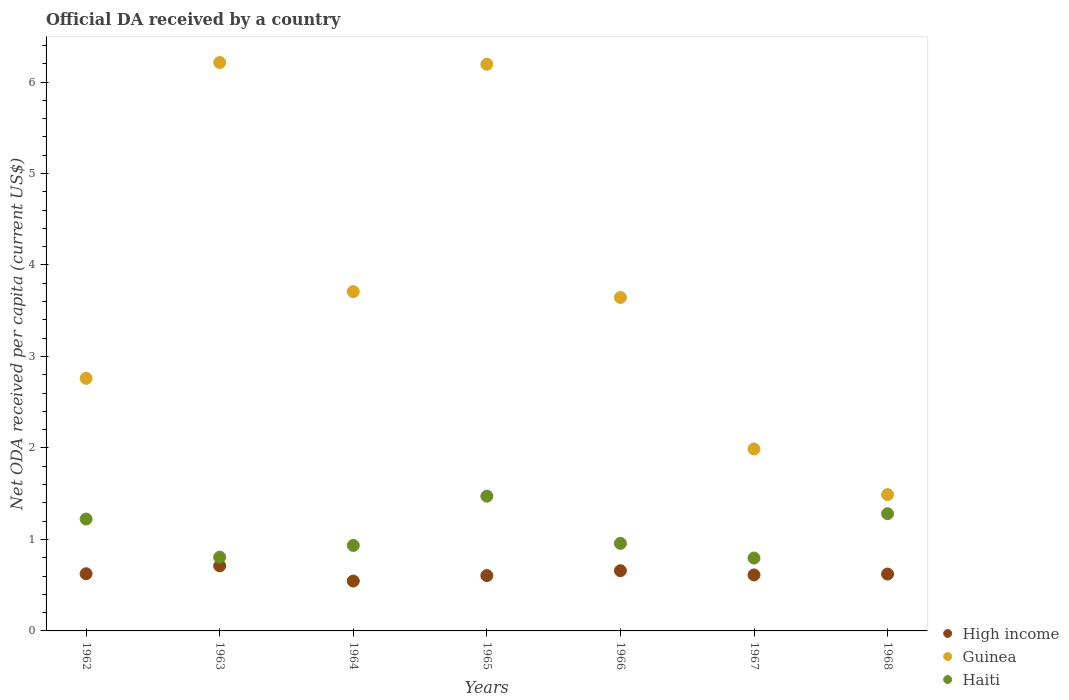How many different coloured dotlines are there?
Offer a terse response. 3. What is the ODA received in in High income in 1963?
Offer a terse response. 0.71. Across all years, what is the maximum ODA received in in High income?
Make the answer very short. 0.71. Across all years, what is the minimum ODA received in in Guinea?
Offer a very short reply. 1.49. In which year was the ODA received in in Guinea maximum?
Ensure brevity in your answer.  1963. In which year was the ODA received in in Guinea minimum?
Your answer should be compact. 1968. What is the total ODA received in in High income in the graph?
Make the answer very short. 4.38. What is the difference between the ODA received in in Guinea in 1964 and that in 1968?
Give a very brief answer. 2.22. What is the difference between the ODA received in in High income in 1964 and the ODA received in in Haiti in 1963?
Provide a succinct answer. -0.26. What is the average ODA received in in High income per year?
Make the answer very short. 0.63. In the year 1963, what is the difference between the ODA received in in High income and ODA received in in Guinea?
Your response must be concise. -5.5. In how many years, is the ODA received in in High income greater than 1.2 US$?
Offer a very short reply. 0. What is the ratio of the ODA received in in High income in 1962 to that in 1967?
Make the answer very short. 1.02. Is the difference between the ODA received in in High income in 1967 and 1968 greater than the difference between the ODA received in in Guinea in 1967 and 1968?
Your response must be concise. No. What is the difference between the highest and the second highest ODA received in in High income?
Offer a terse response. 0.05. What is the difference between the highest and the lowest ODA received in in High income?
Give a very brief answer. 0.17. In how many years, is the ODA received in in Guinea greater than the average ODA received in in Guinea taken over all years?
Provide a short and direct response. 2. Does the ODA received in in Guinea monotonically increase over the years?
Your response must be concise. No. Is the ODA received in in High income strictly less than the ODA received in in Haiti over the years?
Your answer should be very brief. Yes. How many dotlines are there?
Provide a short and direct response. 3. What is the difference between two consecutive major ticks on the Y-axis?
Ensure brevity in your answer.  1. Does the graph contain any zero values?
Keep it short and to the point. No. How many legend labels are there?
Offer a very short reply. 3. What is the title of the graph?
Offer a terse response. Official DA received by a country. Does "Lesotho" appear as one of the legend labels in the graph?
Provide a short and direct response. No. What is the label or title of the X-axis?
Offer a terse response. Years. What is the label or title of the Y-axis?
Your answer should be compact. Net ODA received per capita (current US$). What is the Net ODA received per capita (current US$) of High income in 1962?
Your answer should be compact. 0.63. What is the Net ODA received per capita (current US$) in Guinea in 1962?
Your response must be concise. 2.76. What is the Net ODA received per capita (current US$) in Haiti in 1962?
Provide a succinct answer. 1.22. What is the Net ODA received per capita (current US$) of High income in 1963?
Your response must be concise. 0.71. What is the Net ODA received per capita (current US$) of Guinea in 1963?
Your answer should be very brief. 6.21. What is the Net ODA received per capita (current US$) in Haiti in 1963?
Provide a succinct answer. 0.81. What is the Net ODA received per capita (current US$) of High income in 1964?
Keep it short and to the point. 0.55. What is the Net ODA received per capita (current US$) in Guinea in 1964?
Offer a terse response. 3.71. What is the Net ODA received per capita (current US$) of Haiti in 1964?
Your answer should be very brief. 0.93. What is the Net ODA received per capita (current US$) in High income in 1965?
Your answer should be compact. 0.61. What is the Net ODA received per capita (current US$) in Guinea in 1965?
Your answer should be compact. 6.19. What is the Net ODA received per capita (current US$) in Haiti in 1965?
Your answer should be very brief. 1.47. What is the Net ODA received per capita (current US$) of High income in 1966?
Your answer should be very brief. 0.66. What is the Net ODA received per capita (current US$) of Guinea in 1966?
Provide a succinct answer. 3.64. What is the Net ODA received per capita (current US$) in Haiti in 1966?
Give a very brief answer. 0.96. What is the Net ODA received per capita (current US$) of High income in 1967?
Your answer should be very brief. 0.61. What is the Net ODA received per capita (current US$) in Guinea in 1967?
Your response must be concise. 1.99. What is the Net ODA received per capita (current US$) in Haiti in 1967?
Keep it short and to the point. 0.8. What is the Net ODA received per capita (current US$) of High income in 1968?
Make the answer very short. 0.62. What is the Net ODA received per capita (current US$) in Guinea in 1968?
Provide a short and direct response. 1.49. What is the Net ODA received per capita (current US$) in Haiti in 1968?
Provide a succinct answer. 1.28. Across all years, what is the maximum Net ODA received per capita (current US$) of High income?
Ensure brevity in your answer.  0.71. Across all years, what is the maximum Net ODA received per capita (current US$) of Guinea?
Make the answer very short. 6.21. Across all years, what is the maximum Net ODA received per capita (current US$) of Haiti?
Provide a short and direct response. 1.47. Across all years, what is the minimum Net ODA received per capita (current US$) in High income?
Your answer should be very brief. 0.55. Across all years, what is the minimum Net ODA received per capita (current US$) in Guinea?
Your answer should be very brief. 1.49. Across all years, what is the minimum Net ODA received per capita (current US$) of Haiti?
Offer a very short reply. 0.8. What is the total Net ODA received per capita (current US$) in High income in the graph?
Your answer should be very brief. 4.38. What is the total Net ODA received per capita (current US$) of Guinea in the graph?
Provide a succinct answer. 26. What is the total Net ODA received per capita (current US$) of Haiti in the graph?
Offer a very short reply. 7.47. What is the difference between the Net ODA received per capita (current US$) of High income in 1962 and that in 1963?
Your answer should be very brief. -0.09. What is the difference between the Net ODA received per capita (current US$) of Guinea in 1962 and that in 1963?
Your answer should be very brief. -3.45. What is the difference between the Net ODA received per capita (current US$) in Haiti in 1962 and that in 1963?
Your response must be concise. 0.42. What is the difference between the Net ODA received per capita (current US$) of High income in 1962 and that in 1964?
Make the answer very short. 0.08. What is the difference between the Net ODA received per capita (current US$) of Guinea in 1962 and that in 1964?
Make the answer very short. -0.95. What is the difference between the Net ODA received per capita (current US$) in Haiti in 1962 and that in 1964?
Offer a very short reply. 0.29. What is the difference between the Net ODA received per capita (current US$) of Guinea in 1962 and that in 1965?
Provide a succinct answer. -3.43. What is the difference between the Net ODA received per capita (current US$) in Haiti in 1962 and that in 1965?
Your answer should be very brief. -0.25. What is the difference between the Net ODA received per capita (current US$) in High income in 1962 and that in 1966?
Keep it short and to the point. -0.03. What is the difference between the Net ODA received per capita (current US$) of Guinea in 1962 and that in 1966?
Offer a terse response. -0.88. What is the difference between the Net ODA received per capita (current US$) of Haiti in 1962 and that in 1966?
Make the answer very short. 0.27. What is the difference between the Net ODA received per capita (current US$) in High income in 1962 and that in 1967?
Ensure brevity in your answer.  0.01. What is the difference between the Net ODA received per capita (current US$) in Guinea in 1962 and that in 1967?
Your answer should be compact. 0.77. What is the difference between the Net ODA received per capita (current US$) in Haiti in 1962 and that in 1967?
Offer a very short reply. 0.43. What is the difference between the Net ODA received per capita (current US$) of High income in 1962 and that in 1968?
Ensure brevity in your answer.  0. What is the difference between the Net ODA received per capita (current US$) in Guinea in 1962 and that in 1968?
Your response must be concise. 1.27. What is the difference between the Net ODA received per capita (current US$) in Haiti in 1962 and that in 1968?
Give a very brief answer. -0.06. What is the difference between the Net ODA received per capita (current US$) of High income in 1963 and that in 1964?
Provide a succinct answer. 0.17. What is the difference between the Net ODA received per capita (current US$) of Guinea in 1963 and that in 1964?
Your response must be concise. 2.5. What is the difference between the Net ODA received per capita (current US$) of Haiti in 1963 and that in 1964?
Provide a succinct answer. -0.13. What is the difference between the Net ODA received per capita (current US$) in High income in 1963 and that in 1965?
Offer a terse response. 0.11. What is the difference between the Net ODA received per capita (current US$) of Guinea in 1963 and that in 1965?
Make the answer very short. 0.02. What is the difference between the Net ODA received per capita (current US$) in Haiti in 1963 and that in 1965?
Provide a short and direct response. -0.67. What is the difference between the Net ODA received per capita (current US$) of High income in 1963 and that in 1966?
Offer a very short reply. 0.05. What is the difference between the Net ODA received per capita (current US$) in Guinea in 1963 and that in 1966?
Your answer should be compact. 2.57. What is the difference between the Net ODA received per capita (current US$) in Haiti in 1963 and that in 1966?
Offer a terse response. -0.15. What is the difference between the Net ODA received per capita (current US$) in High income in 1963 and that in 1967?
Give a very brief answer. 0.1. What is the difference between the Net ODA received per capita (current US$) in Guinea in 1963 and that in 1967?
Make the answer very short. 4.22. What is the difference between the Net ODA received per capita (current US$) in Haiti in 1963 and that in 1967?
Ensure brevity in your answer.  0.01. What is the difference between the Net ODA received per capita (current US$) of High income in 1963 and that in 1968?
Give a very brief answer. 0.09. What is the difference between the Net ODA received per capita (current US$) in Guinea in 1963 and that in 1968?
Ensure brevity in your answer.  4.72. What is the difference between the Net ODA received per capita (current US$) in Haiti in 1963 and that in 1968?
Keep it short and to the point. -0.47. What is the difference between the Net ODA received per capita (current US$) in High income in 1964 and that in 1965?
Offer a terse response. -0.06. What is the difference between the Net ODA received per capita (current US$) of Guinea in 1964 and that in 1965?
Offer a very short reply. -2.48. What is the difference between the Net ODA received per capita (current US$) of Haiti in 1964 and that in 1965?
Make the answer very short. -0.54. What is the difference between the Net ODA received per capita (current US$) of High income in 1964 and that in 1966?
Provide a succinct answer. -0.11. What is the difference between the Net ODA received per capita (current US$) in Guinea in 1964 and that in 1966?
Offer a terse response. 0.06. What is the difference between the Net ODA received per capita (current US$) of Haiti in 1964 and that in 1966?
Your answer should be very brief. -0.02. What is the difference between the Net ODA received per capita (current US$) in High income in 1964 and that in 1967?
Give a very brief answer. -0.07. What is the difference between the Net ODA received per capita (current US$) in Guinea in 1964 and that in 1967?
Your response must be concise. 1.72. What is the difference between the Net ODA received per capita (current US$) in Haiti in 1964 and that in 1967?
Make the answer very short. 0.14. What is the difference between the Net ODA received per capita (current US$) of High income in 1964 and that in 1968?
Provide a short and direct response. -0.08. What is the difference between the Net ODA received per capita (current US$) of Guinea in 1964 and that in 1968?
Make the answer very short. 2.22. What is the difference between the Net ODA received per capita (current US$) of Haiti in 1964 and that in 1968?
Offer a terse response. -0.35. What is the difference between the Net ODA received per capita (current US$) of High income in 1965 and that in 1966?
Give a very brief answer. -0.05. What is the difference between the Net ODA received per capita (current US$) in Guinea in 1965 and that in 1966?
Provide a succinct answer. 2.55. What is the difference between the Net ODA received per capita (current US$) of Haiti in 1965 and that in 1966?
Provide a short and direct response. 0.52. What is the difference between the Net ODA received per capita (current US$) in High income in 1965 and that in 1967?
Your response must be concise. -0.01. What is the difference between the Net ODA received per capita (current US$) of Guinea in 1965 and that in 1967?
Your answer should be compact. 4.21. What is the difference between the Net ODA received per capita (current US$) in Haiti in 1965 and that in 1967?
Provide a succinct answer. 0.68. What is the difference between the Net ODA received per capita (current US$) in High income in 1965 and that in 1968?
Your response must be concise. -0.02. What is the difference between the Net ODA received per capita (current US$) of Guinea in 1965 and that in 1968?
Offer a very short reply. 4.7. What is the difference between the Net ODA received per capita (current US$) of Haiti in 1965 and that in 1968?
Give a very brief answer. 0.19. What is the difference between the Net ODA received per capita (current US$) of High income in 1966 and that in 1967?
Your answer should be compact. 0.05. What is the difference between the Net ODA received per capita (current US$) in Guinea in 1966 and that in 1967?
Your response must be concise. 1.66. What is the difference between the Net ODA received per capita (current US$) of Haiti in 1966 and that in 1967?
Make the answer very short. 0.16. What is the difference between the Net ODA received per capita (current US$) in High income in 1966 and that in 1968?
Keep it short and to the point. 0.04. What is the difference between the Net ODA received per capita (current US$) of Guinea in 1966 and that in 1968?
Your response must be concise. 2.15. What is the difference between the Net ODA received per capita (current US$) of Haiti in 1966 and that in 1968?
Keep it short and to the point. -0.32. What is the difference between the Net ODA received per capita (current US$) in High income in 1967 and that in 1968?
Make the answer very short. -0.01. What is the difference between the Net ODA received per capita (current US$) in Guinea in 1967 and that in 1968?
Keep it short and to the point. 0.5. What is the difference between the Net ODA received per capita (current US$) in Haiti in 1967 and that in 1968?
Provide a short and direct response. -0.49. What is the difference between the Net ODA received per capita (current US$) in High income in 1962 and the Net ODA received per capita (current US$) in Guinea in 1963?
Keep it short and to the point. -5.59. What is the difference between the Net ODA received per capita (current US$) of High income in 1962 and the Net ODA received per capita (current US$) of Haiti in 1963?
Keep it short and to the point. -0.18. What is the difference between the Net ODA received per capita (current US$) of Guinea in 1962 and the Net ODA received per capita (current US$) of Haiti in 1963?
Your answer should be compact. 1.95. What is the difference between the Net ODA received per capita (current US$) in High income in 1962 and the Net ODA received per capita (current US$) in Guinea in 1964?
Give a very brief answer. -3.08. What is the difference between the Net ODA received per capita (current US$) of High income in 1962 and the Net ODA received per capita (current US$) of Haiti in 1964?
Give a very brief answer. -0.31. What is the difference between the Net ODA received per capita (current US$) of Guinea in 1962 and the Net ODA received per capita (current US$) of Haiti in 1964?
Provide a short and direct response. 1.83. What is the difference between the Net ODA received per capita (current US$) in High income in 1962 and the Net ODA received per capita (current US$) in Guinea in 1965?
Give a very brief answer. -5.57. What is the difference between the Net ODA received per capita (current US$) of High income in 1962 and the Net ODA received per capita (current US$) of Haiti in 1965?
Offer a terse response. -0.85. What is the difference between the Net ODA received per capita (current US$) of Guinea in 1962 and the Net ODA received per capita (current US$) of Haiti in 1965?
Your answer should be very brief. 1.29. What is the difference between the Net ODA received per capita (current US$) in High income in 1962 and the Net ODA received per capita (current US$) in Guinea in 1966?
Offer a very short reply. -3.02. What is the difference between the Net ODA received per capita (current US$) in High income in 1962 and the Net ODA received per capita (current US$) in Haiti in 1966?
Provide a short and direct response. -0.33. What is the difference between the Net ODA received per capita (current US$) of Guinea in 1962 and the Net ODA received per capita (current US$) of Haiti in 1966?
Give a very brief answer. 1.8. What is the difference between the Net ODA received per capita (current US$) of High income in 1962 and the Net ODA received per capita (current US$) of Guinea in 1967?
Make the answer very short. -1.36. What is the difference between the Net ODA received per capita (current US$) in High income in 1962 and the Net ODA received per capita (current US$) in Haiti in 1967?
Your response must be concise. -0.17. What is the difference between the Net ODA received per capita (current US$) in Guinea in 1962 and the Net ODA received per capita (current US$) in Haiti in 1967?
Offer a very short reply. 1.96. What is the difference between the Net ODA received per capita (current US$) of High income in 1962 and the Net ODA received per capita (current US$) of Guinea in 1968?
Your answer should be very brief. -0.86. What is the difference between the Net ODA received per capita (current US$) of High income in 1962 and the Net ODA received per capita (current US$) of Haiti in 1968?
Ensure brevity in your answer.  -0.66. What is the difference between the Net ODA received per capita (current US$) in Guinea in 1962 and the Net ODA received per capita (current US$) in Haiti in 1968?
Make the answer very short. 1.48. What is the difference between the Net ODA received per capita (current US$) in High income in 1963 and the Net ODA received per capita (current US$) in Guinea in 1964?
Make the answer very short. -3. What is the difference between the Net ODA received per capita (current US$) of High income in 1963 and the Net ODA received per capita (current US$) of Haiti in 1964?
Give a very brief answer. -0.22. What is the difference between the Net ODA received per capita (current US$) of Guinea in 1963 and the Net ODA received per capita (current US$) of Haiti in 1964?
Keep it short and to the point. 5.28. What is the difference between the Net ODA received per capita (current US$) in High income in 1963 and the Net ODA received per capita (current US$) in Guinea in 1965?
Provide a short and direct response. -5.48. What is the difference between the Net ODA received per capita (current US$) of High income in 1963 and the Net ODA received per capita (current US$) of Haiti in 1965?
Make the answer very short. -0.76. What is the difference between the Net ODA received per capita (current US$) of Guinea in 1963 and the Net ODA received per capita (current US$) of Haiti in 1965?
Your answer should be compact. 4.74. What is the difference between the Net ODA received per capita (current US$) of High income in 1963 and the Net ODA received per capita (current US$) of Guinea in 1966?
Provide a succinct answer. -2.93. What is the difference between the Net ODA received per capita (current US$) of High income in 1963 and the Net ODA received per capita (current US$) of Haiti in 1966?
Give a very brief answer. -0.25. What is the difference between the Net ODA received per capita (current US$) in Guinea in 1963 and the Net ODA received per capita (current US$) in Haiti in 1966?
Give a very brief answer. 5.26. What is the difference between the Net ODA received per capita (current US$) in High income in 1963 and the Net ODA received per capita (current US$) in Guinea in 1967?
Your answer should be compact. -1.28. What is the difference between the Net ODA received per capita (current US$) in High income in 1963 and the Net ODA received per capita (current US$) in Haiti in 1967?
Offer a very short reply. -0.09. What is the difference between the Net ODA received per capita (current US$) in Guinea in 1963 and the Net ODA received per capita (current US$) in Haiti in 1967?
Offer a very short reply. 5.42. What is the difference between the Net ODA received per capita (current US$) in High income in 1963 and the Net ODA received per capita (current US$) in Guinea in 1968?
Your answer should be compact. -0.78. What is the difference between the Net ODA received per capita (current US$) of High income in 1963 and the Net ODA received per capita (current US$) of Haiti in 1968?
Provide a succinct answer. -0.57. What is the difference between the Net ODA received per capita (current US$) of Guinea in 1963 and the Net ODA received per capita (current US$) of Haiti in 1968?
Your response must be concise. 4.93. What is the difference between the Net ODA received per capita (current US$) of High income in 1964 and the Net ODA received per capita (current US$) of Guinea in 1965?
Give a very brief answer. -5.65. What is the difference between the Net ODA received per capita (current US$) of High income in 1964 and the Net ODA received per capita (current US$) of Haiti in 1965?
Provide a succinct answer. -0.93. What is the difference between the Net ODA received per capita (current US$) in Guinea in 1964 and the Net ODA received per capita (current US$) in Haiti in 1965?
Provide a short and direct response. 2.24. What is the difference between the Net ODA received per capita (current US$) in High income in 1964 and the Net ODA received per capita (current US$) in Guinea in 1966?
Your answer should be very brief. -3.1. What is the difference between the Net ODA received per capita (current US$) of High income in 1964 and the Net ODA received per capita (current US$) of Haiti in 1966?
Offer a very short reply. -0.41. What is the difference between the Net ODA received per capita (current US$) in Guinea in 1964 and the Net ODA received per capita (current US$) in Haiti in 1966?
Make the answer very short. 2.75. What is the difference between the Net ODA received per capita (current US$) of High income in 1964 and the Net ODA received per capita (current US$) of Guinea in 1967?
Your response must be concise. -1.44. What is the difference between the Net ODA received per capita (current US$) of High income in 1964 and the Net ODA received per capita (current US$) of Haiti in 1967?
Offer a terse response. -0.25. What is the difference between the Net ODA received per capita (current US$) in Guinea in 1964 and the Net ODA received per capita (current US$) in Haiti in 1967?
Provide a succinct answer. 2.91. What is the difference between the Net ODA received per capita (current US$) in High income in 1964 and the Net ODA received per capita (current US$) in Guinea in 1968?
Make the answer very short. -0.94. What is the difference between the Net ODA received per capita (current US$) in High income in 1964 and the Net ODA received per capita (current US$) in Haiti in 1968?
Provide a succinct answer. -0.74. What is the difference between the Net ODA received per capita (current US$) in Guinea in 1964 and the Net ODA received per capita (current US$) in Haiti in 1968?
Offer a very short reply. 2.43. What is the difference between the Net ODA received per capita (current US$) in High income in 1965 and the Net ODA received per capita (current US$) in Guinea in 1966?
Offer a very short reply. -3.04. What is the difference between the Net ODA received per capita (current US$) in High income in 1965 and the Net ODA received per capita (current US$) in Haiti in 1966?
Your answer should be compact. -0.35. What is the difference between the Net ODA received per capita (current US$) in Guinea in 1965 and the Net ODA received per capita (current US$) in Haiti in 1966?
Your answer should be very brief. 5.24. What is the difference between the Net ODA received per capita (current US$) of High income in 1965 and the Net ODA received per capita (current US$) of Guinea in 1967?
Offer a terse response. -1.38. What is the difference between the Net ODA received per capita (current US$) of High income in 1965 and the Net ODA received per capita (current US$) of Haiti in 1967?
Give a very brief answer. -0.19. What is the difference between the Net ODA received per capita (current US$) in Guinea in 1965 and the Net ODA received per capita (current US$) in Haiti in 1967?
Keep it short and to the point. 5.4. What is the difference between the Net ODA received per capita (current US$) in High income in 1965 and the Net ODA received per capita (current US$) in Guinea in 1968?
Your response must be concise. -0.88. What is the difference between the Net ODA received per capita (current US$) in High income in 1965 and the Net ODA received per capita (current US$) in Haiti in 1968?
Offer a very short reply. -0.68. What is the difference between the Net ODA received per capita (current US$) of Guinea in 1965 and the Net ODA received per capita (current US$) of Haiti in 1968?
Your answer should be compact. 4.91. What is the difference between the Net ODA received per capita (current US$) of High income in 1966 and the Net ODA received per capita (current US$) of Guinea in 1967?
Offer a very short reply. -1.33. What is the difference between the Net ODA received per capita (current US$) of High income in 1966 and the Net ODA received per capita (current US$) of Haiti in 1967?
Keep it short and to the point. -0.14. What is the difference between the Net ODA received per capita (current US$) of Guinea in 1966 and the Net ODA received per capita (current US$) of Haiti in 1967?
Offer a terse response. 2.85. What is the difference between the Net ODA received per capita (current US$) in High income in 1966 and the Net ODA received per capita (current US$) in Guinea in 1968?
Make the answer very short. -0.83. What is the difference between the Net ODA received per capita (current US$) in High income in 1966 and the Net ODA received per capita (current US$) in Haiti in 1968?
Offer a very short reply. -0.62. What is the difference between the Net ODA received per capita (current US$) of Guinea in 1966 and the Net ODA received per capita (current US$) of Haiti in 1968?
Ensure brevity in your answer.  2.36. What is the difference between the Net ODA received per capita (current US$) of High income in 1967 and the Net ODA received per capita (current US$) of Guinea in 1968?
Keep it short and to the point. -0.88. What is the difference between the Net ODA received per capita (current US$) of High income in 1967 and the Net ODA received per capita (current US$) of Haiti in 1968?
Offer a terse response. -0.67. What is the difference between the Net ODA received per capita (current US$) of Guinea in 1967 and the Net ODA received per capita (current US$) of Haiti in 1968?
Make the answer very short. 0.71. What is the average Net ODA received per capita (current US$) of High income per year?
Offer a terse response. 0.63. What is the average Net ODA received per capita (current US$) in Guinea per year?
Give a very brief answer. 3.71. What is the average Net ODA received per capita (current US$) in Haiti per year?
Give a very brief answer. 1.07. In the year 1962, what is the difference between the Net ODA received per capita (current US$) in High income and Net ODA received per capita (current US$) in Guinea?
Offer a terse response. -2.14. In the year 1962, what is the difference between the Net ODA received per capita (current US$) in High income and Net ODA received per capita (current US$) in Haiti?
Provide a short and direct response. -0.6. In the year 1962, what is the difference between the Net ODA received per capita (current US$) in Guinea and Net ODA received per capita (current US$) in Haiti?
Make the answer very short. 1.54. In the year 1963, what is the difference between the Net ODA received per capita (current US$) of High income and Net ODA received per capita (current US$) of Guinea?
Give a very brief answer. -5.5. In the year 1963, what is the difference between the Net ODA received per capita (current US$) of High income and Net ODA received per capita (current US$) of Haiti?
Your response must be concise. -0.1. In the year 1963, what is the difference between the Net ODA received per capita (current US$) of Guinea and Net ODA received per capita (current US$) of Haiti?
Keep it short and to the point. 5.41. In the year 1964, what is the difference between the Net ODA received per capita (current US$) of High income and Net ODA received per capita (current US$) of Guinea?
Keep it short and to the point. -3.16. In the year 1964, what is the difference between the Net ODA received per capita (current US$) in High income and Net ODA received per capita (current US$) in Haiti?
Make the answer very short. -0.39. In the year 1964, what is the difference between the Net ODA received per capita (current US$) of Guinea and Net ODA received per capita (current US$) of Haiti?
Your response must be concise. 2.78. In the year 1965, what is the difference between the Net ODA received per capita (current US$) of High income and Net ODA received per capita (current US$) of Guinea?
Your response must be concise. -5.59. In the year 1965, what is the difference between the Net ODA received per capita (current US$) in High income and Net ODA received per capita (current US$) in Haiti?
Provide a short and direct response. -0.87. In the year 1965, what is the difference between the Net ODA received per capita (current US$) of Guinea and Net ODA received per capita (current US$) of Haiti?
Give a very brief answer. 4.72. In the year 1966, what is the difference between the Net ODA received per capita (current US$) of High income and Net ODA received per capita (current US$) of Guinea?
Offer a terse response. -2.99. In the year 1966, what is the difference between the Net ODA received per capita (current US$) of High income and Net ODA received per capita (current US$) of Haiti?
Offer a terse response. -0.3. In the year 1966, what is the difference between the Net ODA received per capita (current US$) of Guinea and Net ODA received per capita (current US$) of Haiti?
Give a very brief answer. 2.69. In the year 1967, what is the difference between the Net ODA received per capita (current US$) in High income and Net ODA received per capita (current US$) in Guinea?
Your answer should be compact. -1.38. In the year 1967, what is the difference between the Net ODA received per capita (current US$) of High income and Net ODA received per capita (current US$) of Haiti?
Your response must be concise. -0.18. In the year 1967, what is the difference between the Net ODA received per capita (current US$) of Guinea and Net ODA received per capita (current US$) of Haiti?
Provide a short and direct response. 1.19. In the year 1968, what is the difference between the Net ODA received per capita (current US$) in High income and Net ODA received per capita (current US$) in Guinea?
Offer a terse response. -0.87. In the year 1968, what is the difference between the Net ODA received per capita (current US$) in High income and Net ODA received per capita (current US$) in Haiti?
Offer a terse response. -0.66. In the year 1968, what is the difference between the Net ODA received per capita (current US$) of Guinea and Net ODA received per capita (current US$) of Haiti?
Offer a very short reply. 0.21. What is the ratio of the Net ODA received per capita (current US$) of High income in 1962 to that in 1963?
Ensure brevity in your answer.  0.88. What is the ratio of the Net ODA received per capita (current US$) of Guinea in 1962 to that in 1963?
Your answer should be very brief. 0.44. What is the ratio of the Net ODA received per capita (current US$) of Haiti in 1962 to that in 1963?
Give a very brief answer. 1.52. What is the ratio of the Net ODA received per capita (current US$) in High income in 1962 to that in 1964?
Your response must be concise. 1.15. What is the ratio of the Net ODA received per capita (current US$) of Guinea in 1962 to that in 1964?
Ensure brevity in your answer.  0.74. What is the ratio of the Net ODA received per capita (current US$) of Haiti in 1962 to that in 1964?
Your answer should be compact. 1.31. What is the ratio of the Net ODA received per capita (current US$) in High income in 1962 to that in 1965?
Offer a terse response. 1.03. What is the ratio of the Net ODA received per capita (current US$) in Guinea in 1962 to that in 1965?
Offer a terse response. 0.45. What is the ratio of the Net ODA received per capita (current US$) of Haiti in 1962 to that in 1965?
Provide a short and direct response. 0.83. What is the ratio of the Net ODA received per capita (current US$) of High income in 1962 to that in 1966?
Your answer should be very brief. 0.95. What is the ratio of the Net ODA received per capita (current US$) of Guinea in 1962 to that in 1966?
Your answer should be compact. 0.76. What is the ratio of the Net ODA received per capita (current US$) of Haiti in 1962 to that in 1966?
Your answer should be compact. 1.28. What is the ratio of the Net ODA received per capita (current US$) of High income in 1962 to that in 1967?
Offer a very short reply. 1.02. What is the ratio of the Net ODA received per capita (current US$) of Guinea in 1962 to that in 1967?
Keep it short and to the point. 1.39. What is the ratio of the Net ODA received per capita (current US$) in Haiti in 1962 to that in 1967?
Your answer should be compact. 1.54. What is the ratio of the Net ODA received per capita (current US$) of High income in 1962 to that in 1968?
Your response must be concise. 1.01. What is the ratio of the Net ODA received per capita (current US$) of Guinea in 1962 to that in 1968?
Your answer should be very brief. 1.85. What is the ratio of the Net ODA received per capita (current US$) in Haiti in 1962 to that in 1968?
Provide a short and direct response. 0.95. What is the ratio of the Net ODA received per capita (current US$) of High income in 1963 to that in 1964?
Your answer should be compact. 1.3. What is the ratio of the Net ODA received per capita (current US$) in Guinea in 1963 to that in 1964?
Give a very brief answer. 1.68. What is the ratio of the Net ODA received per capita (current US$) of Haiti in 1963 to that in 1964?
Offer a terse response. 0.86. What is the ratio of the Net ODA received per capita (current US$) of High income in 1963 to that in 1965?
Provide a short and direct response. 1.18. What is the ratio of the Net ODA received per capita (current US$) of Haiti in 1963 to that in 1965?
Offer a terse response. 0.55. What is the ratio of the Net ODA received per capita (current US$) in High income in 1963 to that in 1966?
Your answer should be compact. 1.08. What is the ratio of the Net ODA received per capita (current US$) of Guinea in 1963 to that in 1966?
Give a very brief answer. 1.7. What is the ratio of the Net ODA received per capita (current US$) of Haiti in 1963 to that in 1966?
Your answer should be very brief. 0.84. What is the ratio of the Net ODA received per capita (current US$) in High income in 1963 to that in 1967?
Keep it short and to the point. 1.16. What is the ratio of the Net ODA received per capita (current US$) of Guinea in 1963 to that in 1967?
Offer a very short reply. 3.12. What is the ratio of the Net ODA received per capita (current US$) in Haiti in 1963 to that in 1967?
Make the answer very short. 1.01. What is the ratio of the Net ODA received per capita (current US$) of High income in 1963 to that in 1968?
Provide a succinct answer. 1.14. What is the ratio of the Net ODA received per capita (current US$) in Guinea in 1963 to that in 1968?
Provide a short and direct response. 4.17. What is the ratio of the Net ODA received per capita (current US$) in Haiti in 1963 to that in 1968?
Your response must be concise. 0.63. What is the ratio of the Net ODA received per capita (current US$) of High income in 1964 to that in 1965?
Give a very brief answer. 0.9. What is the ratio of the Net ODA received per capita (current US$) of Guinea in 1964 to that in 1965?
Keep it short and to the point. 0.6. What is the ratio of the Net ODA received per capita (current US$) of Haiti in 1964 to that in 1965?
Provide a succinct answer. 0.63. What is the ratio of the Net ODA received per capita (current US$) of High income in 1964 to that in 1966?
Your response must be concise. 0.83. What is the ratio of the Net ODA received per capita (current US$) in Guinea in 1964 to that in 1966?
Your answer should be compact. 1.02. What is the ratio of the Net ODA received per capita (current US$) in Haiti in 1964 to that in 1966?
Your answer should be very brief. 0.98. What is the ratio of the Net ODA received per capita (current US$) in High income in 1964 to that in 1967?
Your response must be concise. 0.89. What is the ratio of the Net ODA received per capita (current US$) in Guinea in 1964 to that in 1967?
Keep it short and to the point. 1.86. What is the ratio of the Net ODA received per capita (current US$) in Haiti in 1964 to that in 1967?
Make the answer very short. 1.17. What is the ratio of the Net ODA received per capita (current US$) of High income in 1964 to that in 1968?
Offer a terse response. 0.88. What is the ratio of the Net ODA received per capita (current US$) of Guinea in 1964 to that in 1968?
Provide a short and direct response. 2.49. What is the ratio of the Net ODA received per capita (current US$) in Haiti in 1964 to that in 1968?
Keep it short and to the point. 0.73. What is the ratio of the Net ODA received per capita (current US$) of High income in 1965 to that in 1966?
Make the answer very short. 0.92. What is the ratio of the Net ODA received per capita (current US$) in Guinea in 1965 to that in 1966?
Your answer should be compact. 1.7. What is the ratio of the Net ODA received per capita (current US$) in Haiti in 1965 to that in 1966?
Provide a succinct answer. 1.54. What is the ratio of the Net ODA received per capita (current US$) in High income in 1965 to that in 1967?
Offer a very short reply. 0.99. What is the ratio of the Net ODA received per capita (current US$) of Guinea in 1965 to that in 1967?
Your answer should be very brief. 3.11. What is the ratio of the Net ODA received per capita (current US$) in Haiti in 1965 to that in 1967?
Offer a very short reply. 1.85. What is the ratio of the Net ODA received per capita (current US$) in High income in 1965 to that in 1968?
Keep it short and to the point. 0.97. What is the ratio of the Net ODA received per capita (current US$) in Guinea in 1965 to that in 1968?
Your answer should be compact. 4.16. What is the ratio of the Net ODA received per capita (current US$) of Haiti in 1965 to that in 1968?
Give a very brief answer. 1.15. What is the ratio of the Net ODA received per capita (current US$) of High income in 1966 to that in 1967?
Make the answer very short. 1.08. What is the ratio of the Net ODA received per capita (current US$) in Guinea in 1966 to that in 1967?
Your answer should be very brief. 1.83. What is the ratio of the Net ODA received per capita (current US$) in Haiti in 1966 to that in 1967?
Provide a succinct answer. 1.2. What is the ratio of the Net ODA received per capita (current US$) in High income in 1966 to that in 1968?
Keep it short and to the point. 1.06. What is the ratio of the Net ODA received per capita (current US$) of Guinea in 1966 to that in 1968?
Provide a succinct answer. 2.45. What is the ratio of the Net ODA received per capita (current US$) in Haiti in 1966 to that in 1968?
Offer a very short reply. 0.75. What is the ratio of the Net ODA received per capita (current US$) in High income in 1967 to that in 1968?
Your answer should be compact. 0.98. What is the ratio of the Net ODA received per capita (current US$) of Guinea in 1967 to that in 1968?
Give a very brief answer. 1.34. What is the ratio of the Net ODA received per capita (current US$) of Haiti in 1967 to that in 1968?
Ensure brevity in your answer.  0.62. What is the difference between the highest and the second highest Net ODA received per capita (current US$) of High income?
Give a very brief answer. 0.05. What is the difference between the highest and the second highest Net ODA received per capita (current US$) in Guinea?
Your answer should be very brief. 0.02. What is the difference between the highest and the second highest Net ODA received per capita (current US$) of Haiti?
Ensure brevity in your answer.  0.19. What is the difference between the highest and the lowest Net ODA received per capita (current US$) of High income?
Your answer should be compact. 0.17. What is the difference between the highest and the lowest Net ODA received per capita (current US$) of Guinea?
Provide a succinct answer. 4.72. What is the difference between the highest and the lowest Net ODA received per capita (current US$) of Haiti?
Your answer should be very brief. 0.68. 